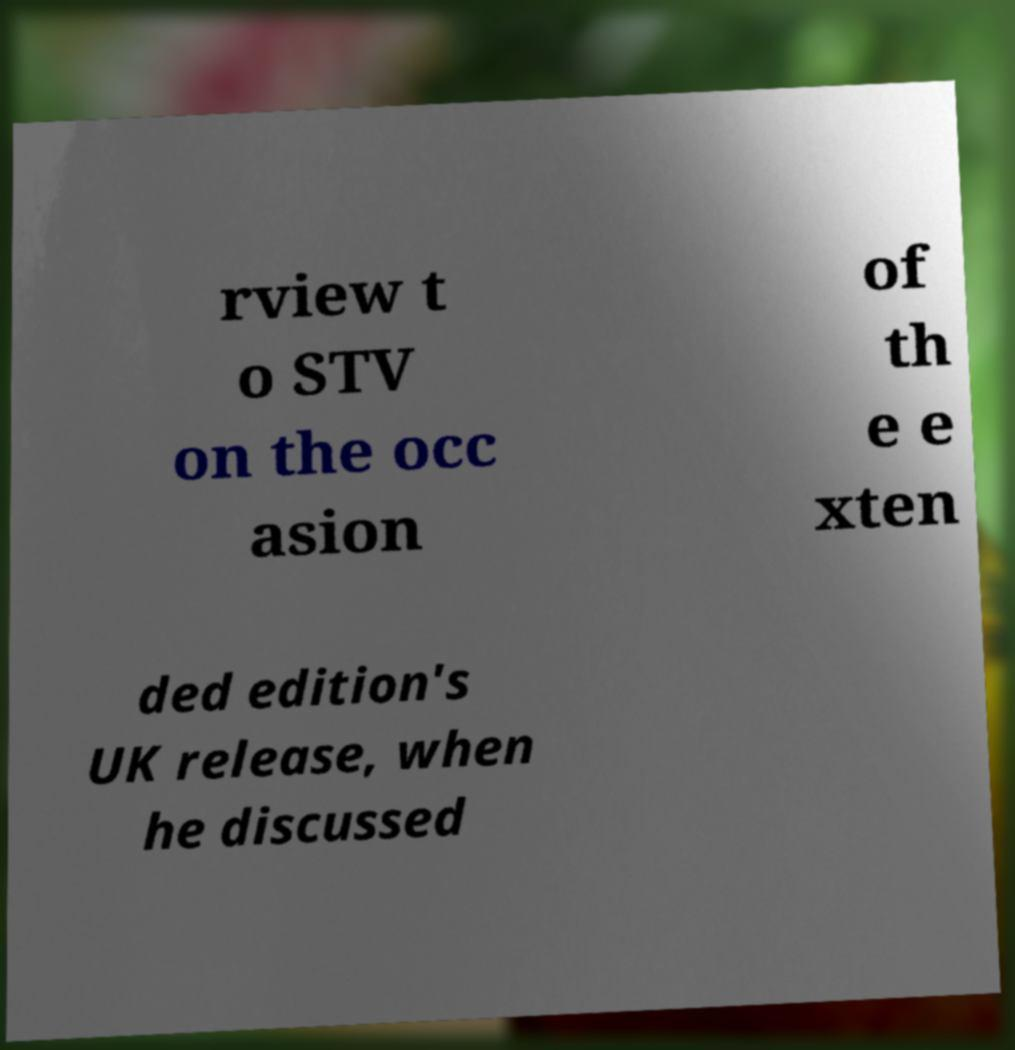Can you accurately transcribe the text from the provided image for me? rview t o STV on the occ asion of th e e xten ded edition's UK release, when he discussed 